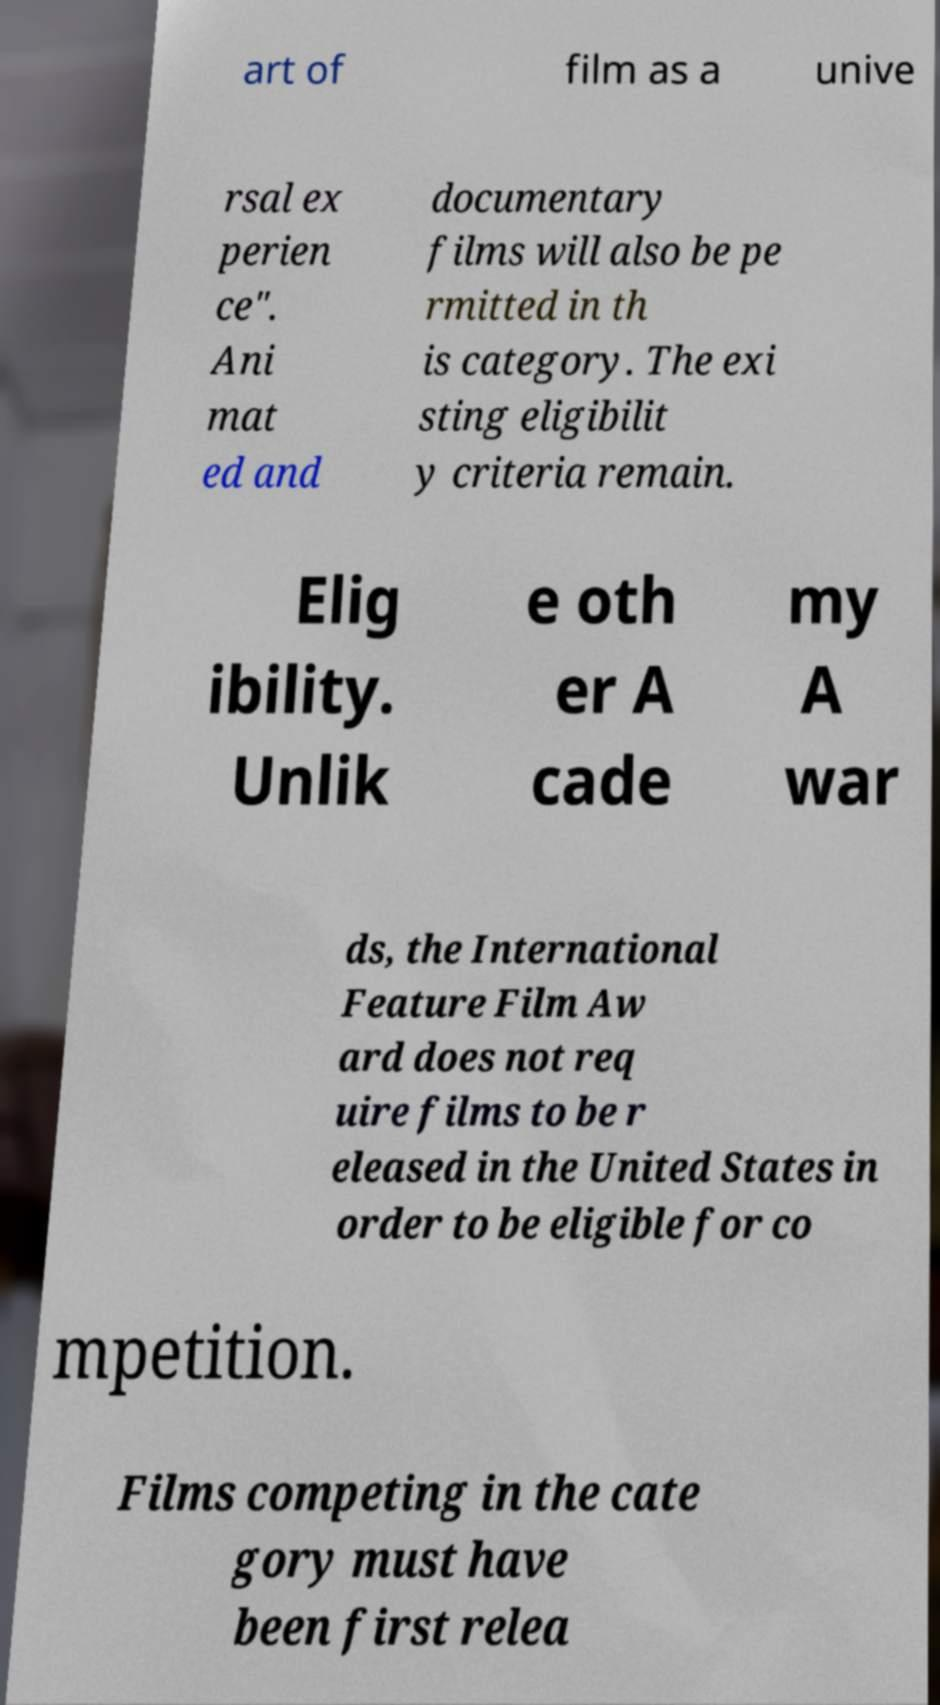I need the written content from this picture converted into text. Can you do that? art of film as a unive rsal ex perien ce". Ani mat ed and documentary films will also be pe rmitted in th is category. The exi sting eligibilit y criteria remain. Elig ibility. Unlik e oth er A cade my A war ds, the International Feature Film Aw ard does not req uire films to be r eleased in the United States in order to be eligible for co mpetition. Films competing in the cate gory must have been first relea 